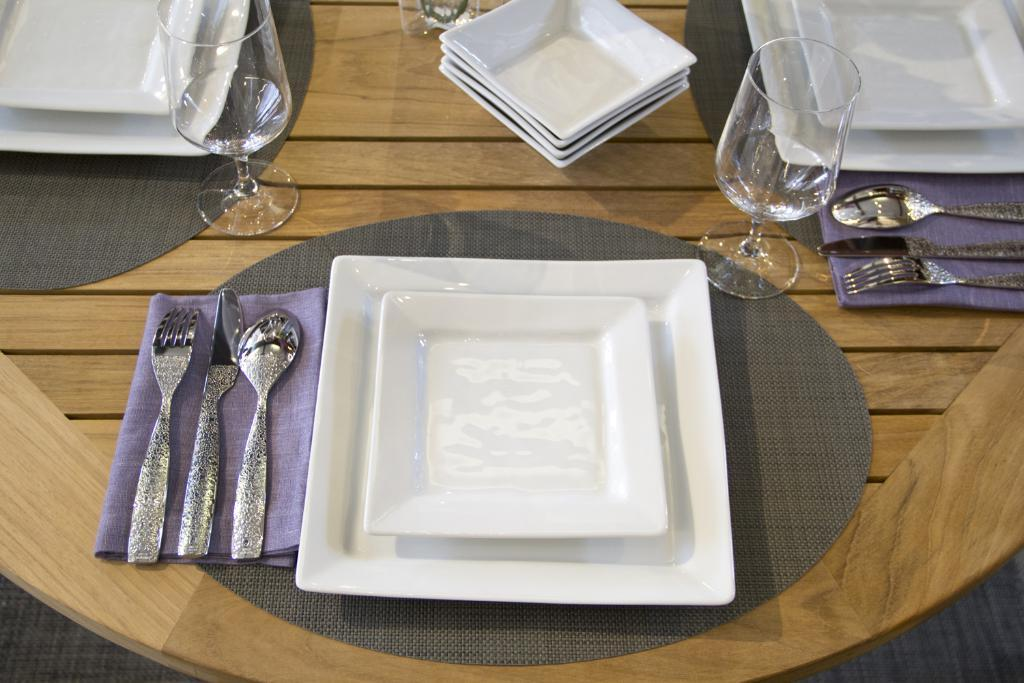What type of dishware is present on the table in the image? There are bowls, glasses, plates, a spoon, a knife, and a fork on the table in the image. What type of surface is the dishware placed on? There is a mat on the table. table in the image. What is the duck's opinion on the profit generated from the table in the image? There is no duck present in the image, and therefore no opinion can be attributed to it. 